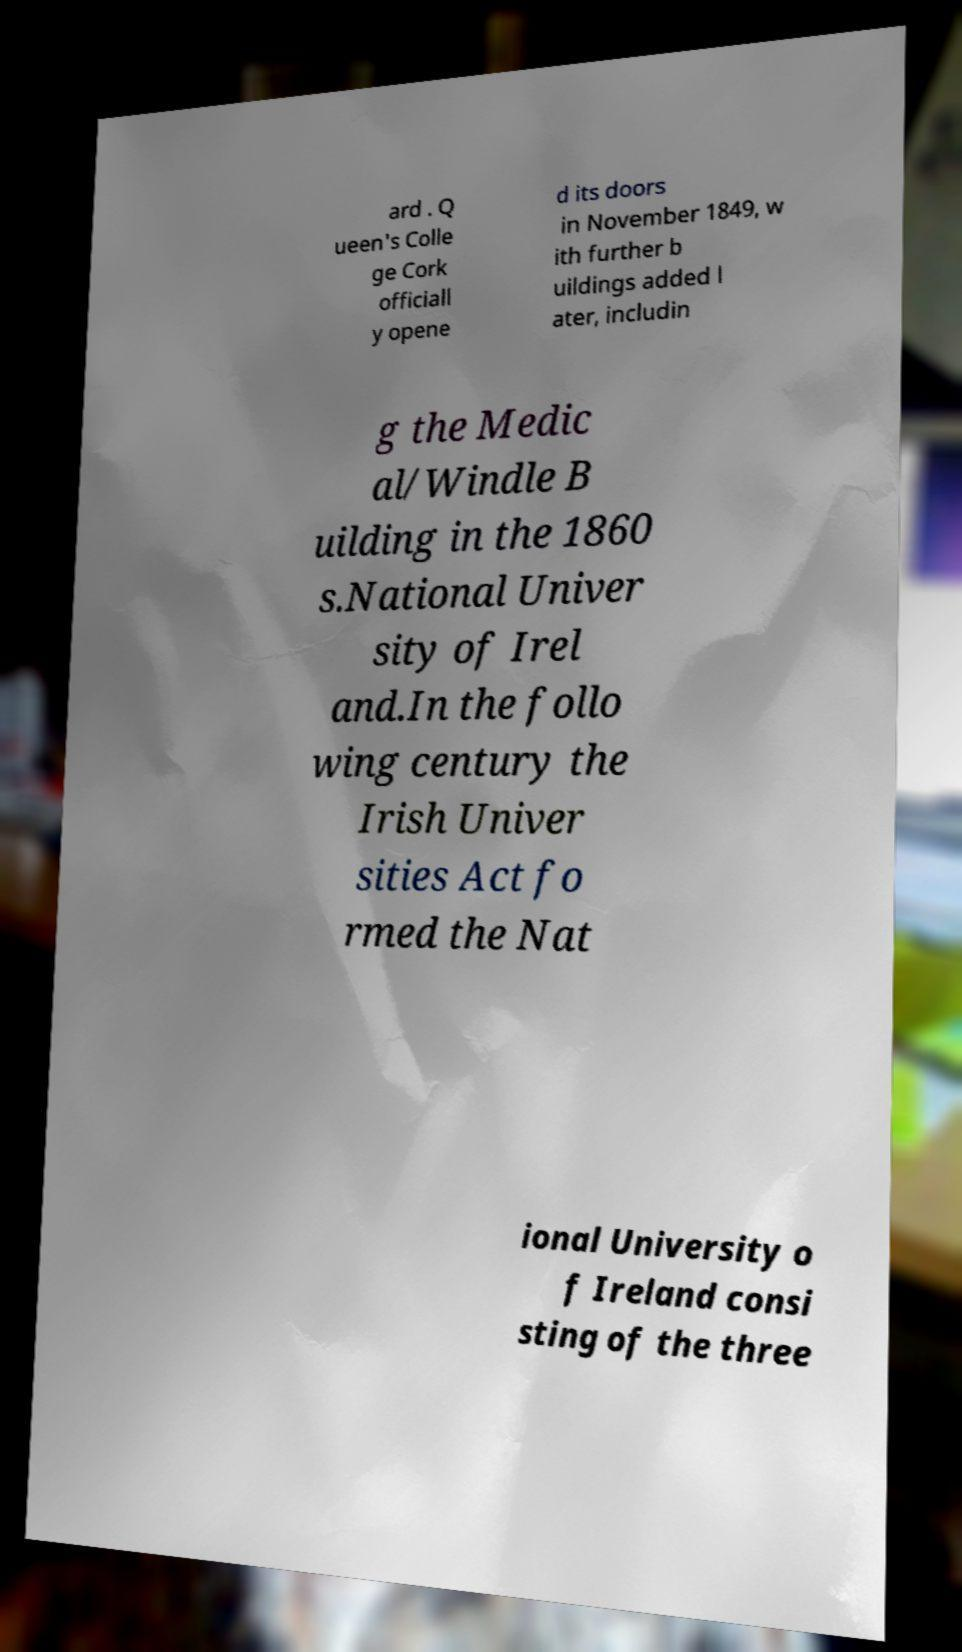There's text embedded in this image that I need extracted. Can you transcribe it verbatim? ard . Q ueen's Colle ge Cork officiall y opene d its doors in November 1849, w ith further b uildings added l ater, includin g the Medic al/Windle B uilding in the 1860 s.National Univer sity of Irel and.In the follo wing century the Irish Univer sities Act fo rmed the Nat ional University o f Ireland consi sting of the three 